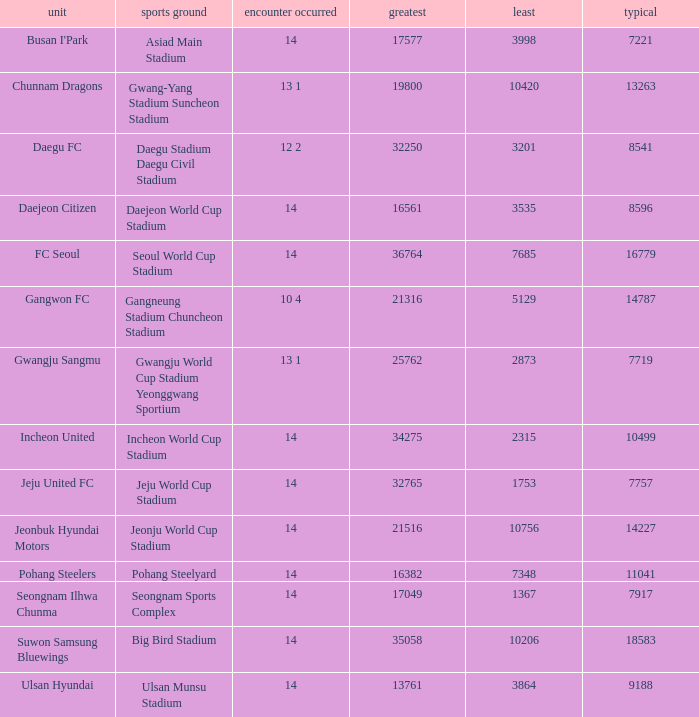Which team has a match played of 10 4? Gangwon FC. 